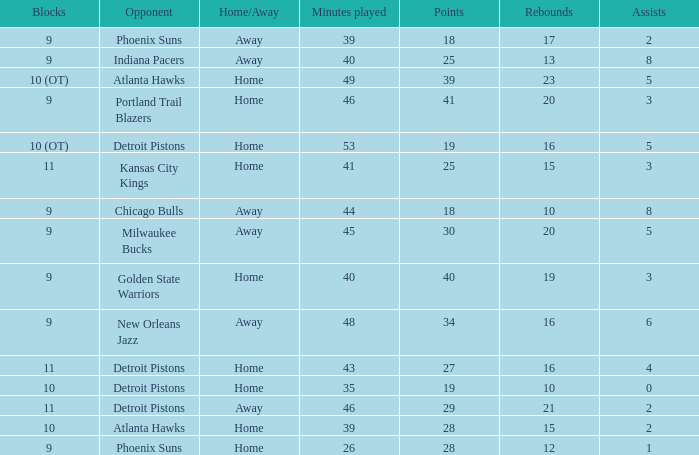How many minutes were played when there were 18 points and the opponent was Chicago Bulls? 1.0. Help me parse the entirety of this table. {'header': ['Blocks', 'Opponent', 'Home/Away', 'Minutes played', 'Points', 'Rebounds', 'Assists'], 'rows': [['9', 'Phoenix Suns', 'Away', '39', '18', '17', '2'], ['9', 'Indiana Pacers', 'Away', '40', '25', '13', '8'], ['10 (OT)', 'Atlanta Hawks', 'Home', '49', '39', '23', '5'], ['9', 'Portland Trail Blazers', 'Home', '46', '41', '20', '3'], ['10 (OT)', 'Detroit Pistons', 'Home', '53', '19', '16', '5'], ['11', 'Kansas City Kings', 'Home', '41', '25', '15', '3'], ['9', 'Chicago Bulls', 'Away', '44', '18', '10', '8'], ['9', 'Milwaukee Bucks', 'Away', '45', '30', '20', '5'], ['9', 'Golden State Warriors', 'Home', '40', '40', '19', '3'], ['9', 'New Orleans Jazz', 'Away', '48', '34', '16', '6'], ['11', 'Detroit Pistons', 'Home', '43', '27', '16', '4'], ['10', 'Detroit Pistons', 'Home', '35', '19', '10', '0'], ['11', 'Detroit Pistons', 'Away', '46', '29', '21', '2'], ['10', 'Atlanta Hawks', 'Home', '39', '28', '15', '2'], ['9', 'Phoenix Suns', 'Home', '26', '28', '12', '1']]} 